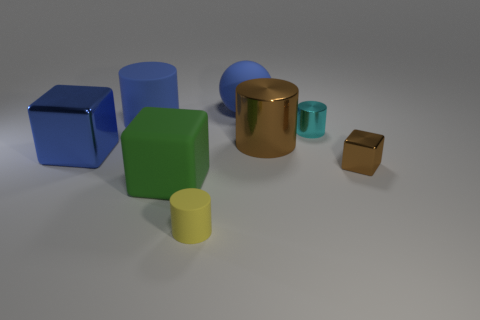There is a matte thing that is the same shape as the large blue shiny thing; what is its color?
Provide a short and direct response. Green. Is there a big yellow ball?
Offer a terse response. No. Do the object that is to the left of the large rubber cylinder and the brown object to the right of the small cyan thing have the same material?
Offer a terse response. Yes. What is the shape of the large thing that is the same color as the tiny metallic cube?
Offer a very short reply. Cylinder. How many things are large blocks to the right of the blue cylinder or things to the right of the big green object?
Provide a short and direct response. 6. There is a small metallic object in front of the cyan thing; is its color the same as the large metallic object to the right of the yellow cylinder?
Make the answer very short. Yes. There is a large blue thing that is on the left side of the large green thing and behind the cyan cylinder; what shape is it?
Keep it short and to the point. Cylinder. There is a shiny thing that is the same size as the cyan metal cylinder; what is its color?
Provide a short and direct response. Brown. Are there any cylinders of the same color as the large sphere?
Make the answer very short. Yes. There is a matte cylinder on the left side of the tiny yellow cylinder; does it have the same size as the metal cube that is on the left side of the brown metal cylinder?
Provide a succinct answer. Yes. 